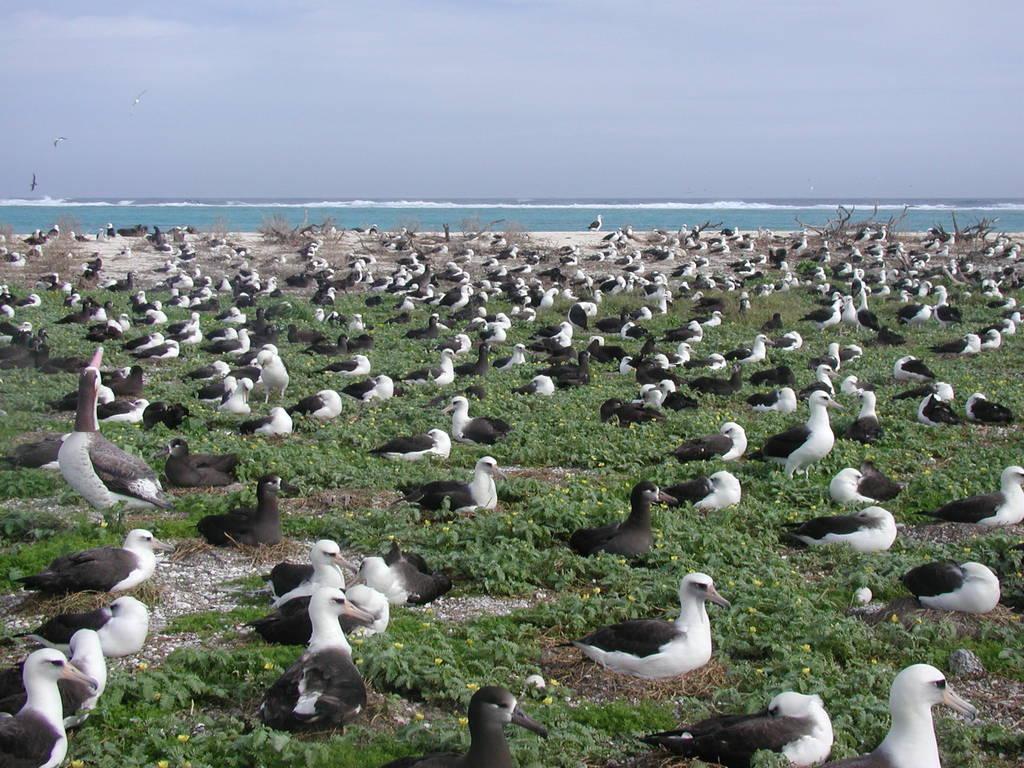Please provide a concise description of this image. This is an outside view. Here I can see many birds on the ground. Along with the birds there are plants. In the background there is a sea. At the top of the image I can see the sky. 